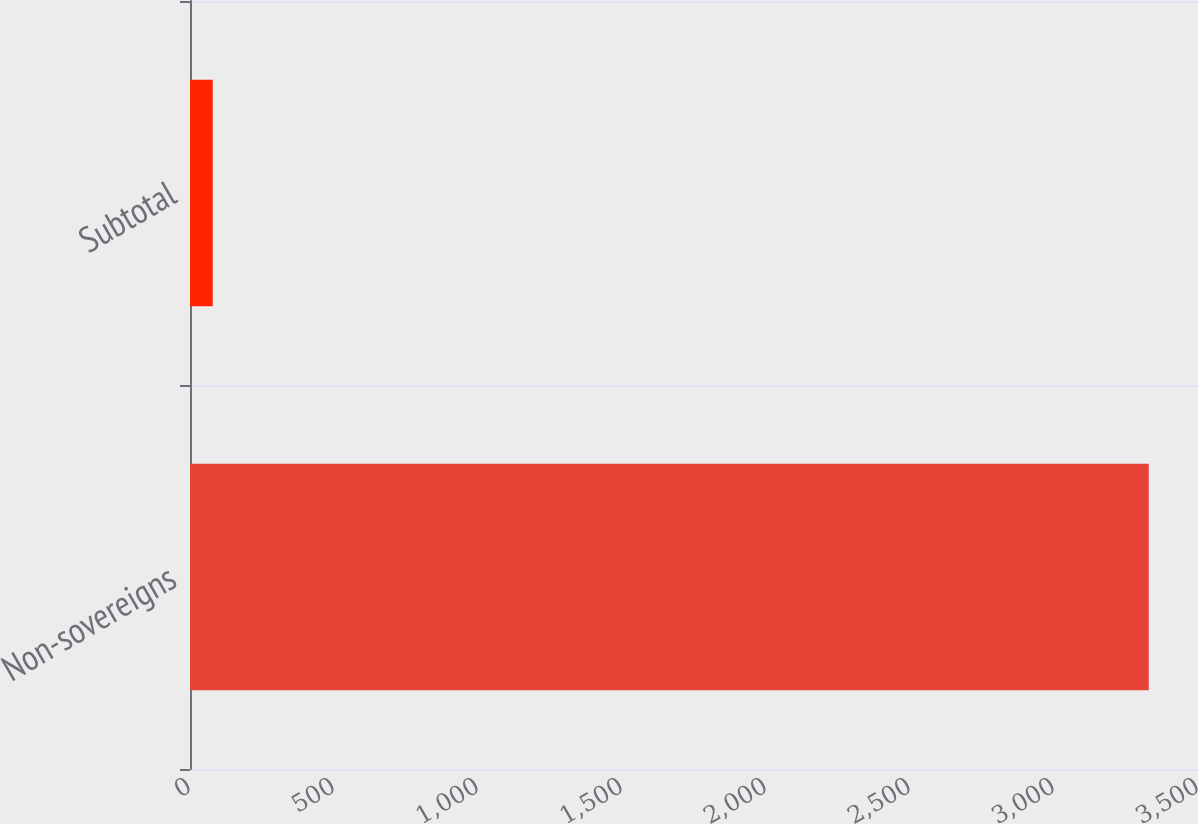Convert chart to OTSL. <chart><loc_0><loc_0><loc_500><loc_500><bar_chart><fcel>Non-sovereigns<fcel>Subtotal<nl><fcel>3329<fcel>79<nl></chart> 